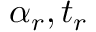<formula> <loc_0><loc_0><loc_500><loc_500>\alpha _ { r } , t _ { r }</formula> 